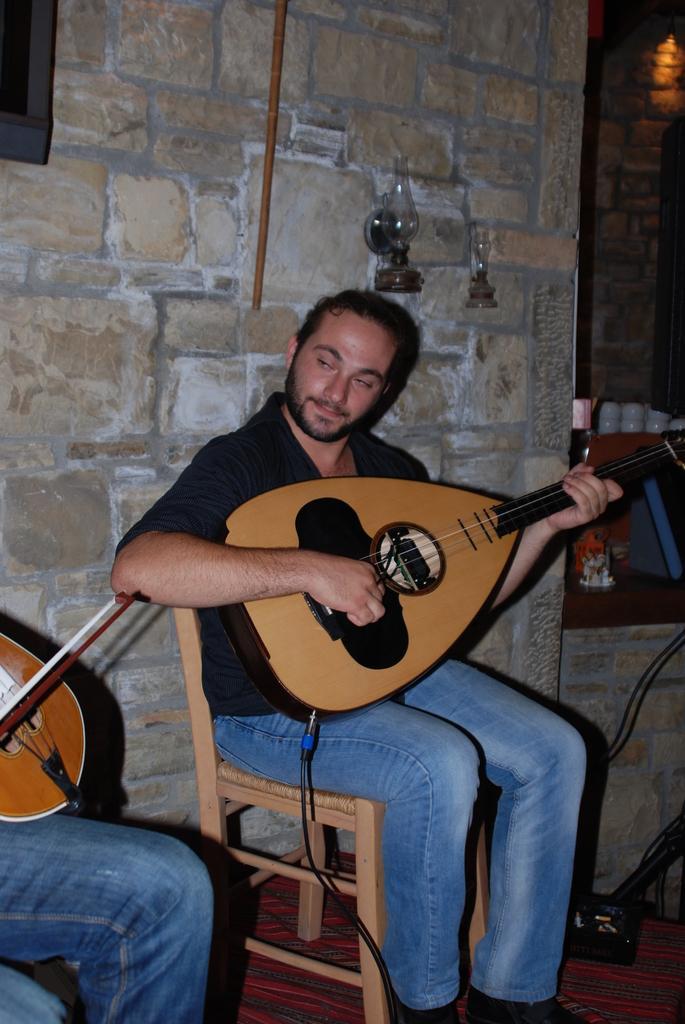Can you describe this image briefly? The person wearing black shirt is sitting and playing guitar and there is another person playing violin beside him. 